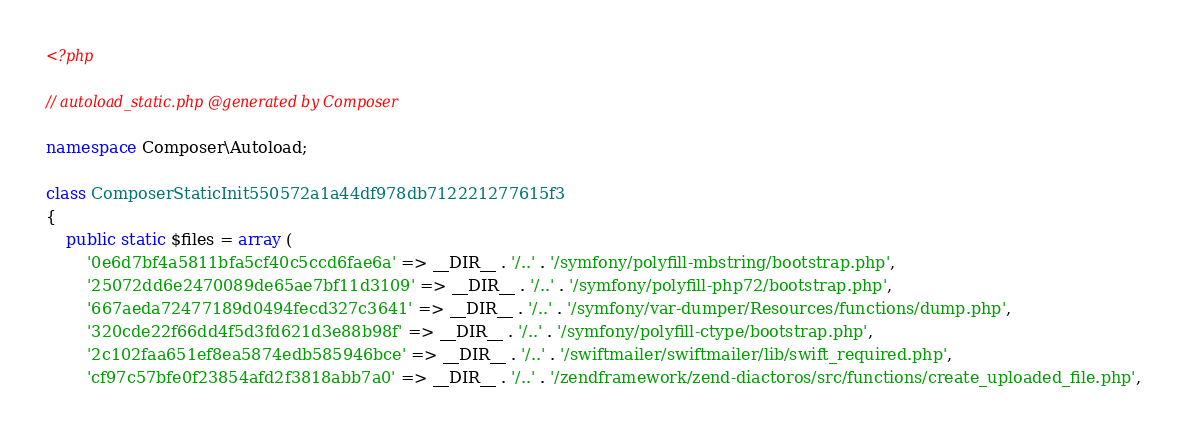Convert code to text. <code><loc_0><loc_0><loc_500><loc_500><_PHP_><?php

// autoload_static.php @generated by Composer

namespace Composer\Autoload;

class ComposerStaticInit550572a1a44df978db712221277615f3
{
    public static $files = array (
        '0e6d7bf4a5811bfa5cf40c5ccd6fae6a' => __DIR__ . '/..' . '/symfony/polyfill-mbstring/bootstrap.php',
        '25072dd6e2470089de65ae7bf11d3109' => __DIR__ . '/..' . '/symfony/polyfill-php72/bootstrap.php',
        '667aeda72477189d0494fecd327c3641' => __DIR__ . '/..' . '/symfony/var-dumper/Resources/functions/dump.php',
        '320cde22f66dd4f5d3fd621d3e88b98f' => __DIR__ . '/..' . '/symfony/polyfill-ctype/bootstrap.php',
        '2c102faa651ef8ea5874edb585946bce' => __DIR__ . '/..' . '/swiftmailer/swiftmailer/lib/swift_required.php',
        'cf97c57bfe0f23854afd2f3818abb7a0' => __DIR__ . '/..' . '/zendframework/zend-diactoros/src/functions/create_uploaded_file.php',</code> 